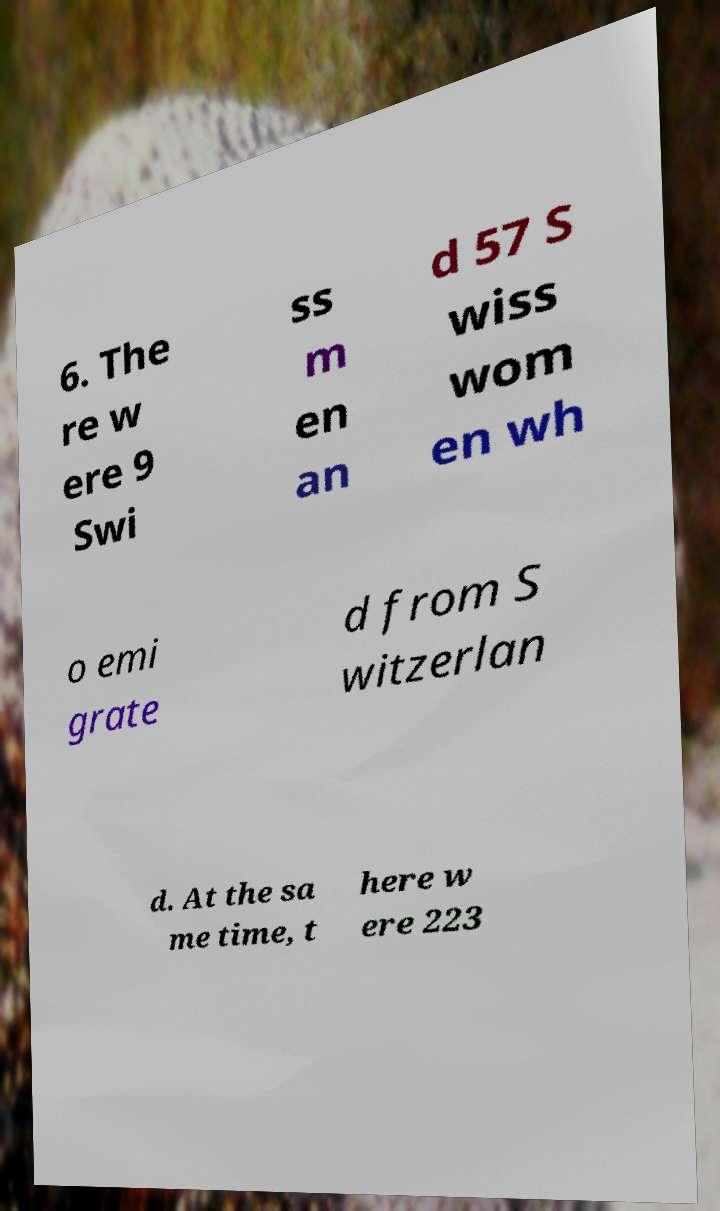For documentation purposes, I need the text within this image transcribed. Could you provide that? 6. The re w ere 9 Swi ss m en an d 57 S wiss wom en wh o emi grate d from S witzerlan d. At the sa me time, t here w ere 223 